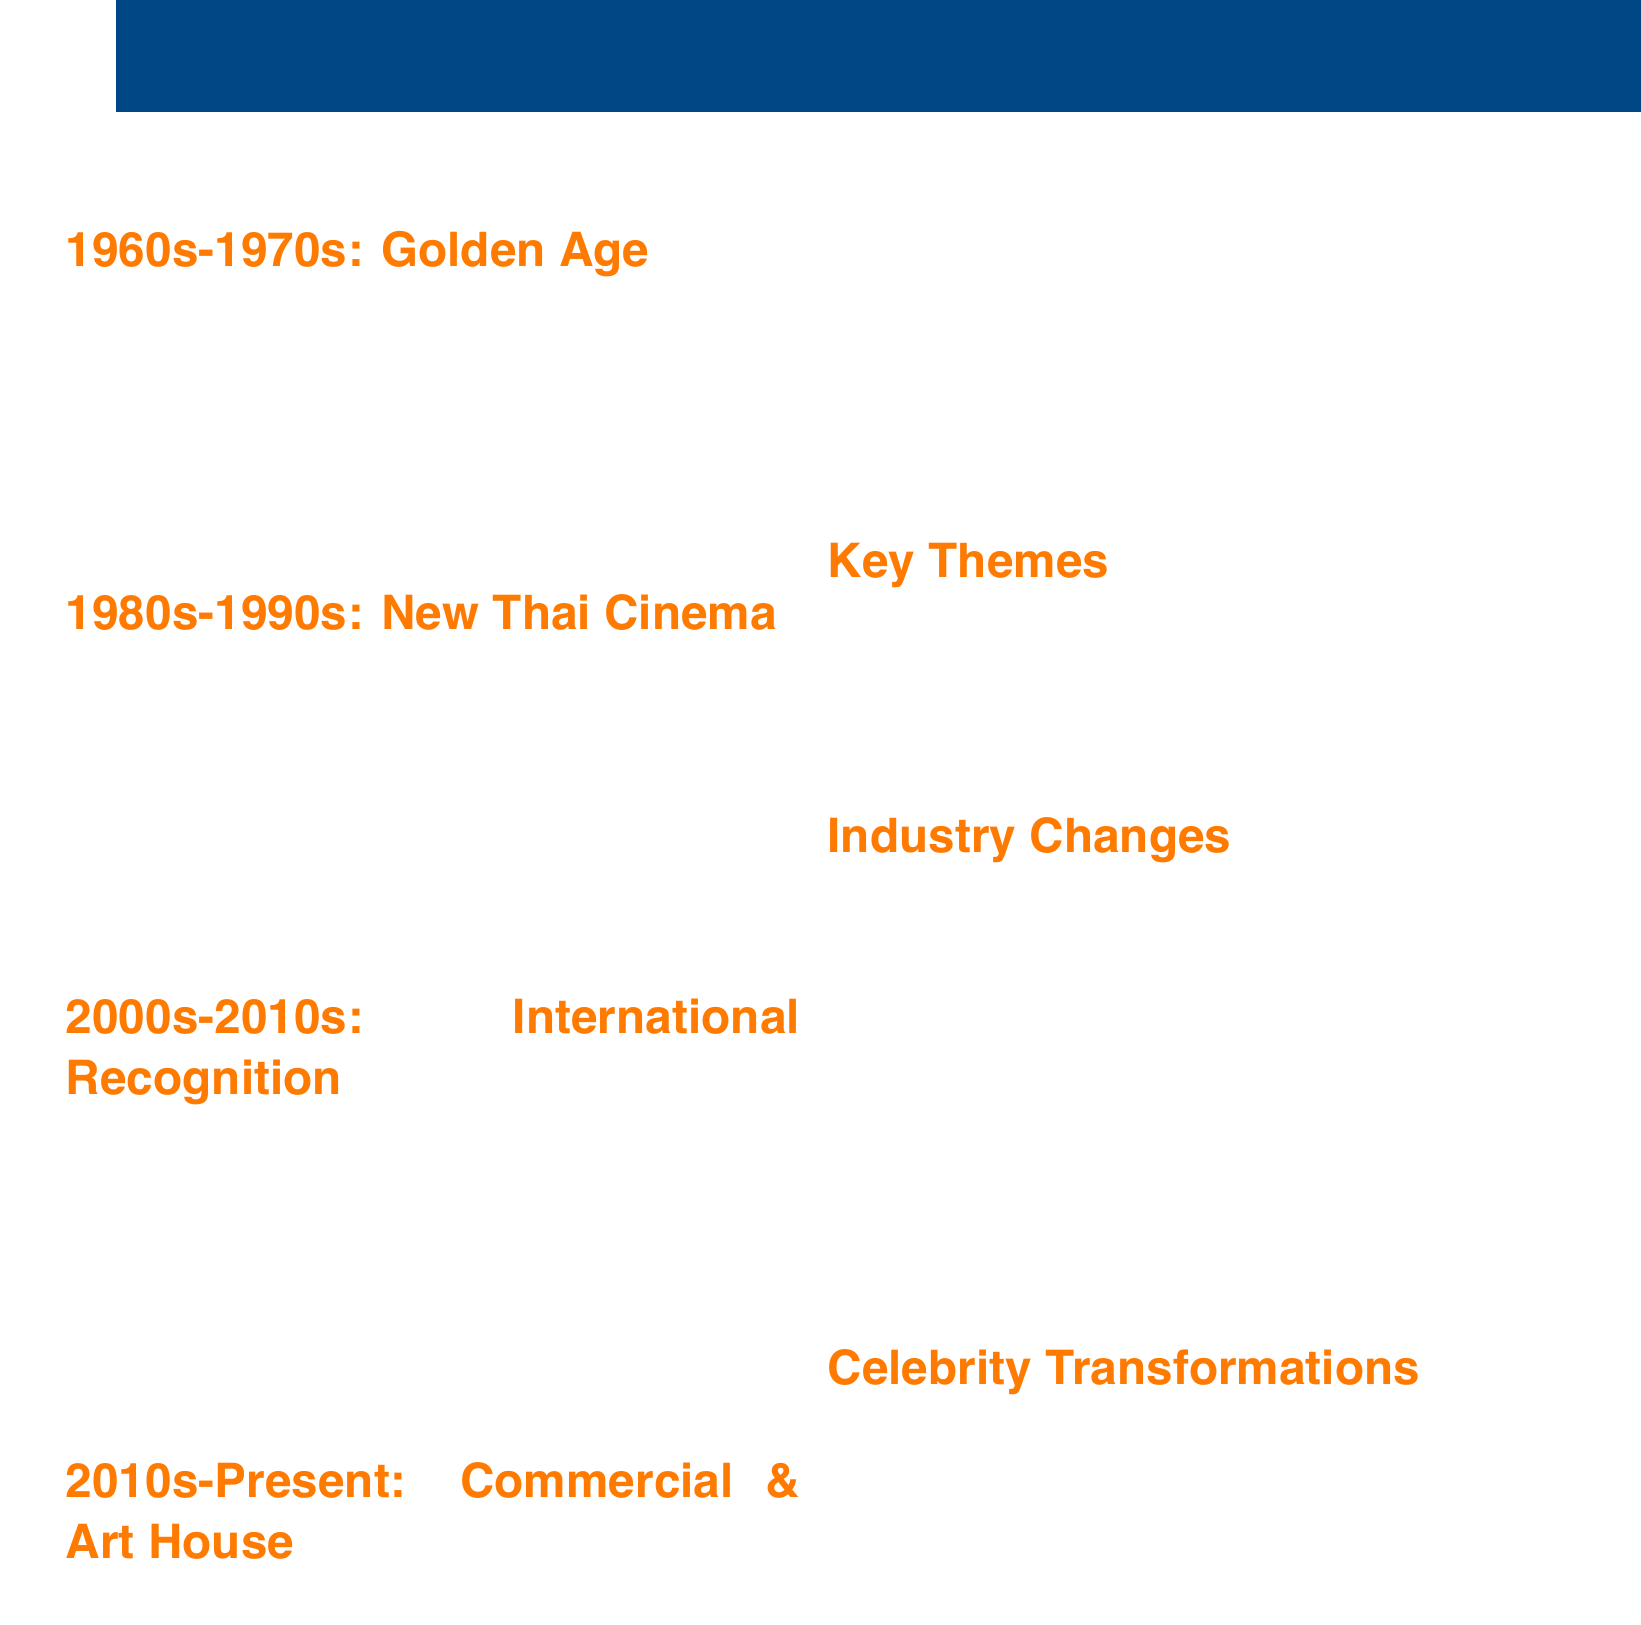What are the key directors of the 1980s-1990s? The key directors of the 1980s-1990s listed in the document are Chatrichalerm Yukol and Nonzee Nimibutr.
Answer: Chatrichalerm Yukol, Nonzee Nimibutr Which influential film was released in 2006? The document mentions "Syndromes and a Century" as a key film released in 2006.
Answer: Syndromes and a Century What significant transformation did Tony Jaa undergo? According to the document, Tony Jaa transformed from a stuntman to an international action star.
Answer: From stuntman to international action star What theme is highlighted in Thai cinema regarding representation? The document lists LGBTQ+ representation as a key theme in Thai cinema.
Answer: LGBTQ+ representation What era is referred to as the Golden Age of Thai cinema? The document describes the era of the 1960s-1970s as the Golden Age of Thai cinema.
Answer: 1960s-1970s Which film from the 2010s highlights commercial cinema? "Bad Genius" is mentioned as a notable film reflecting the rise of commercial cinema in the 2010s.
Answer: Bad Genius What industry change involves increased government support? The document states that there is increased government support and film festivals as a change in the industry.
Answer: Increased government support and film festivals Who directed "Last Life in the Universe"? The key director associated with "Last Life in the Universe," released in 2003, is Pen-Ek Ratanaruang.
Answer: Pen-Ek Ratanaruang What is the main focus of the 2000s-2010s era of Thai cinema? The main focus is on international recognition and the avant-garde movement highlighted in the document.
Answer: International recognition and avant-garde movement 